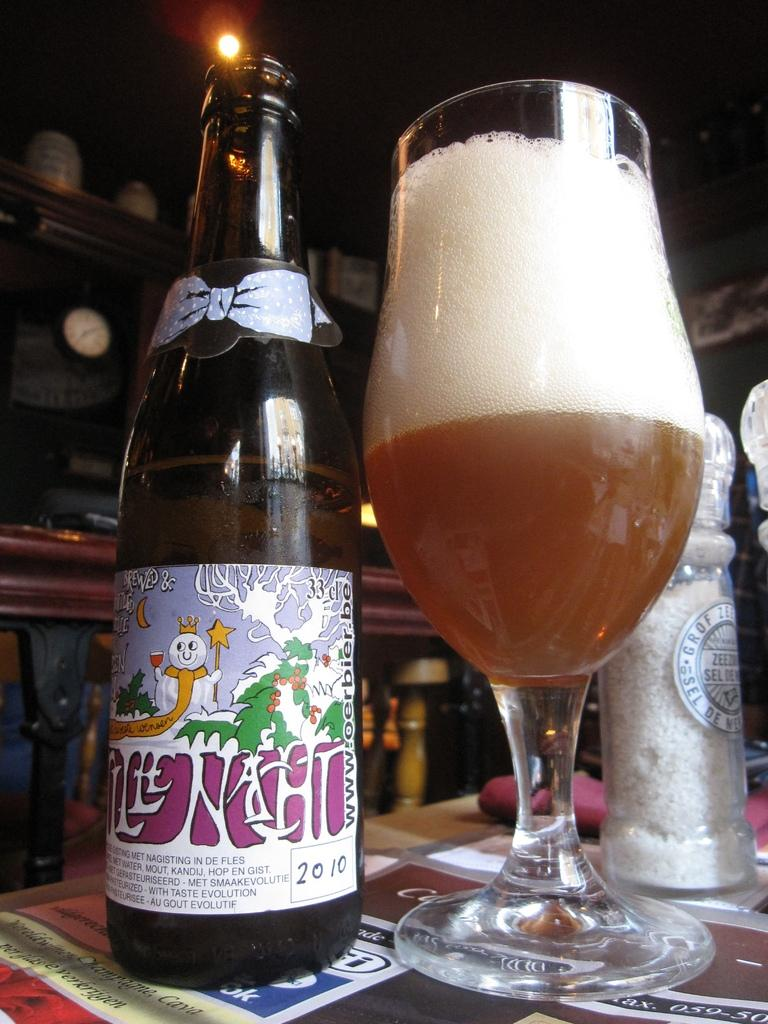<image>
Write a terse but informative summary of the picture. A beer bottle is next to a half full glass and a salt shaker that says Grof Zee. 